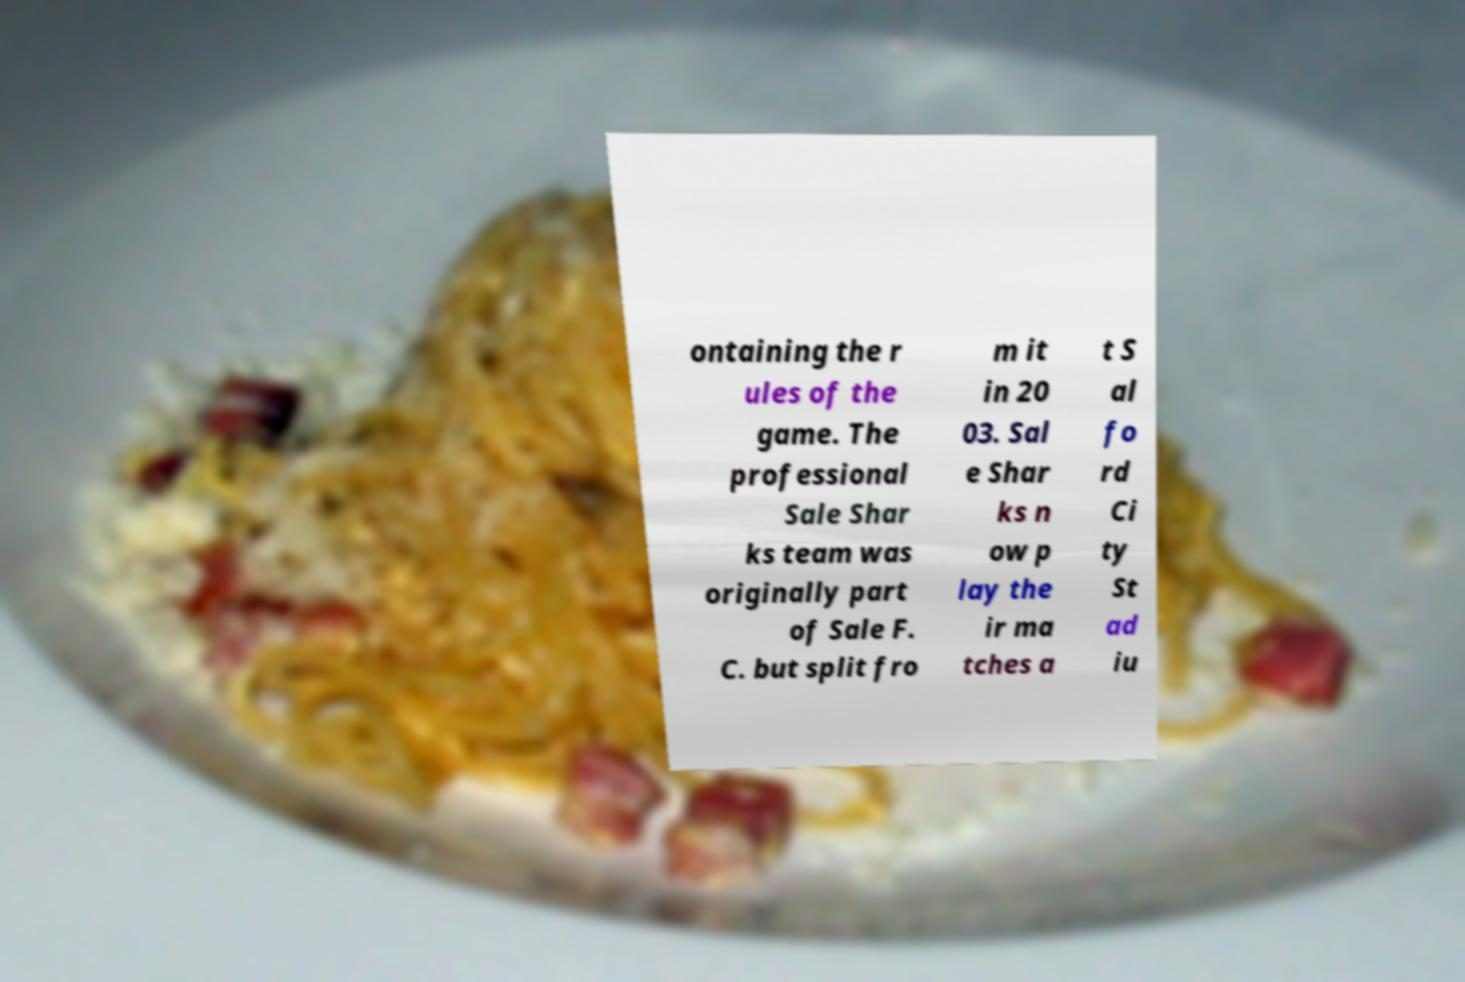Can you accurately transcribe the text from the provided image for me? ontaining the r ules of the game. The professional Sale Shar ks team was originally part of Sale F. C. but split fro m it in 20 03. Sal e Shar ks n ow p lay the ir ma tches a t S al fo rd Ci ty St ad iu 